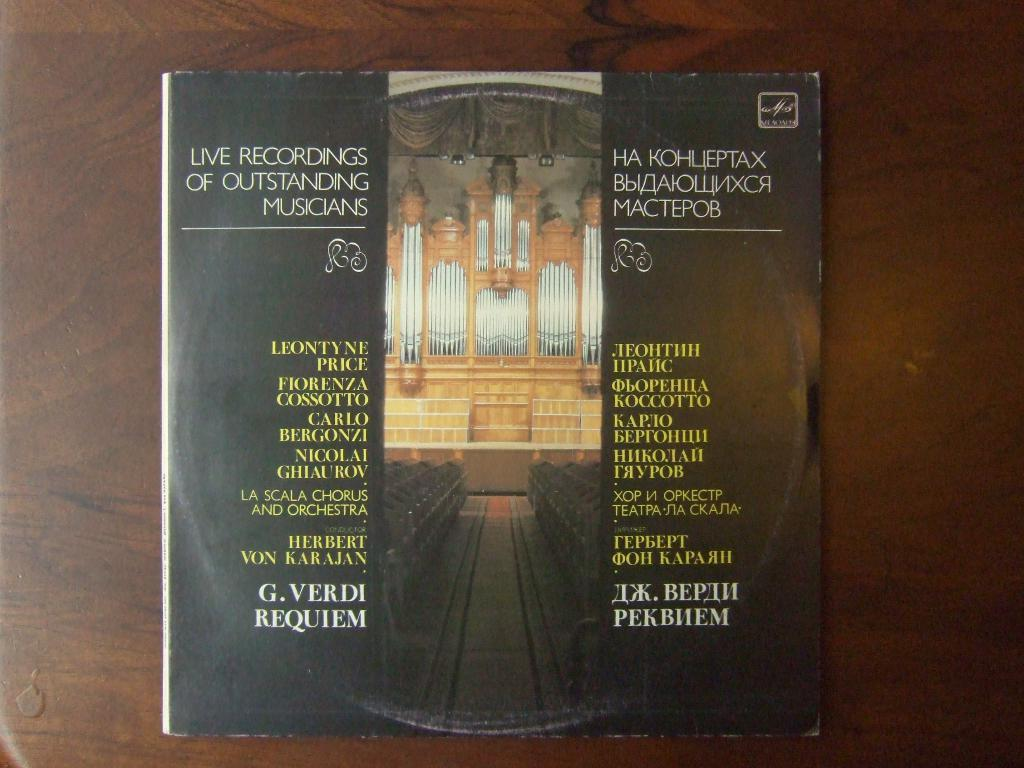<image>
Offer a succinct explanation of the picture presented. A record cover for live recordings of outstanding musicians has a list of musicians. 